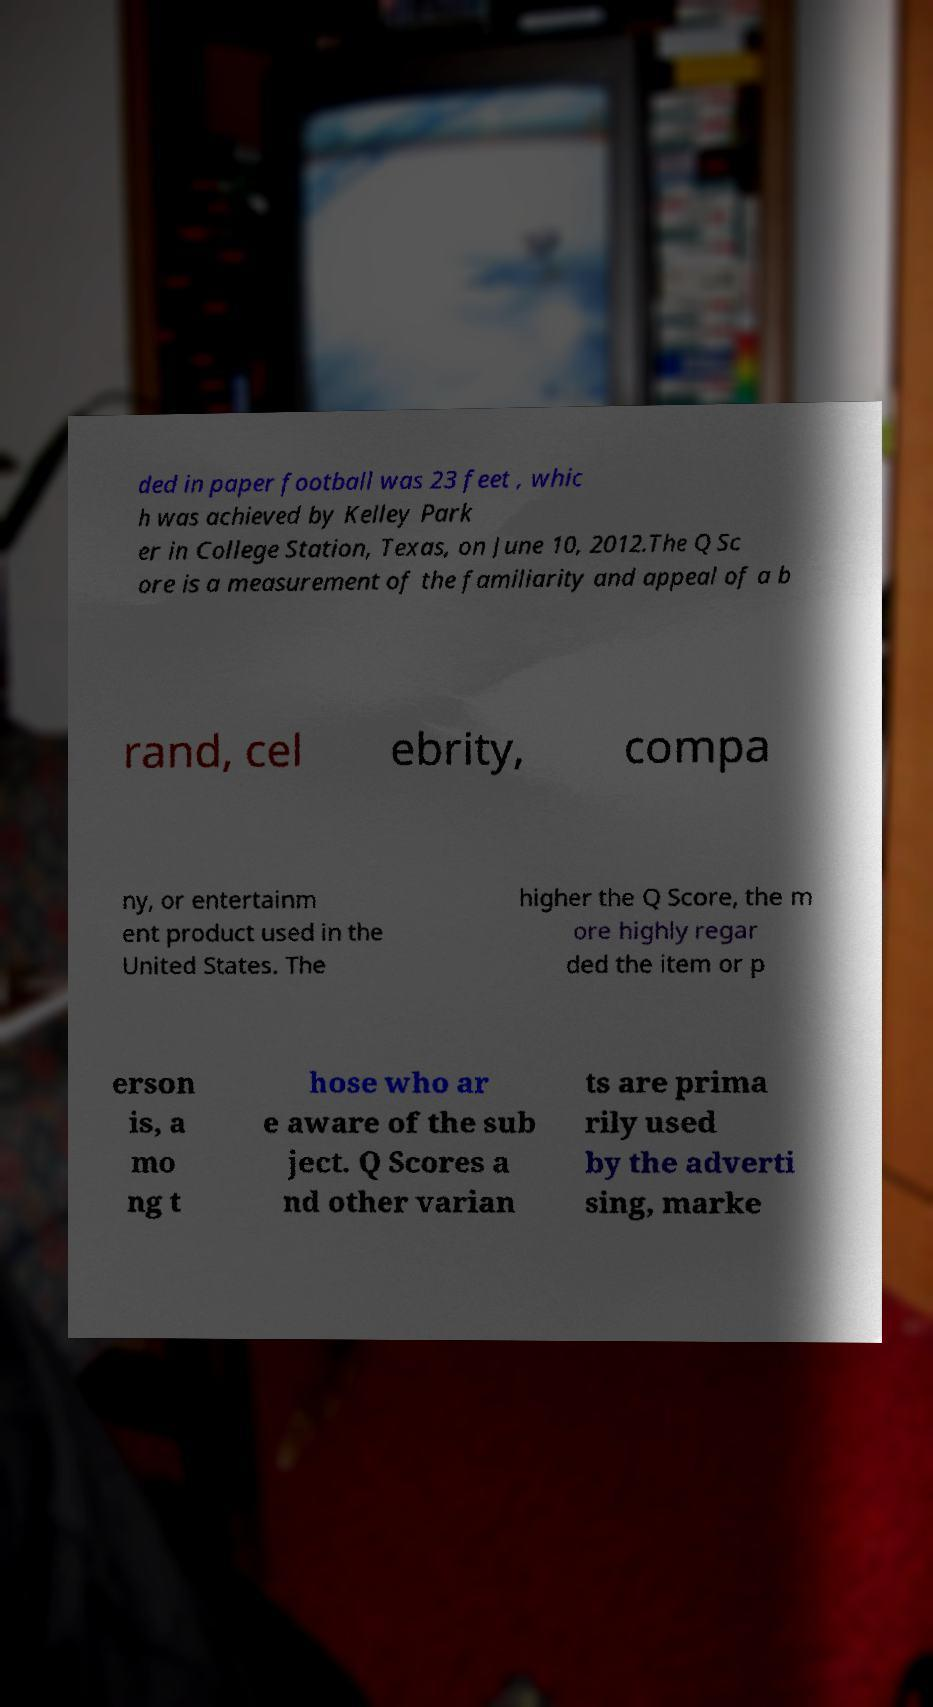Can you read and provide the text displayed in the image?This photo seems to have some interesting text. Can you extract and type it out for me? ded in paper football was 23 feet , whic h was achieved by Kelley Park er in College Station, Texas, on June 10, 2012.The Q Sc ore is a measurement of the familiarity and appeal of a b rand, cel ebrity, compa ny, or entertainm ent product used in the United States. The higher the Q Score, the m ore highly regar ded the item or p erson is, a mo ng t hose who ar e aware of the sub ject. Q Scores a nd other varian ts are prima rily used by the adverti sing, marke 